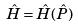Convert formula to latex. <formula><loc_0><loc_0><loc_500><loc_500>\hat { H } = \hat { H } ( \hat { P } )</formula> 